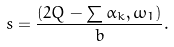Convert formula to latex. <formula><loc_0><loc_0><loc_500><loc_500>s = \frac { ( 2 Q - \sum \alpha _ { k } , \omega _ { 1 } ) } { b } .</formula> 